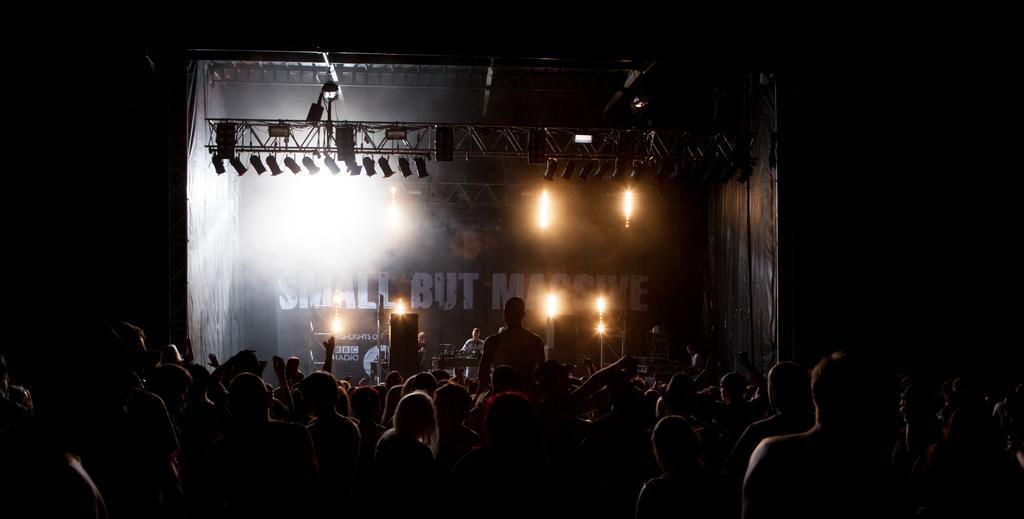Could you give a brief overview of what you see in this image? This picture is taken in the dark, where we can see these people are standing here and these people standing on the stage are playing musical instruments and we can see show lights and the banner in the background. 